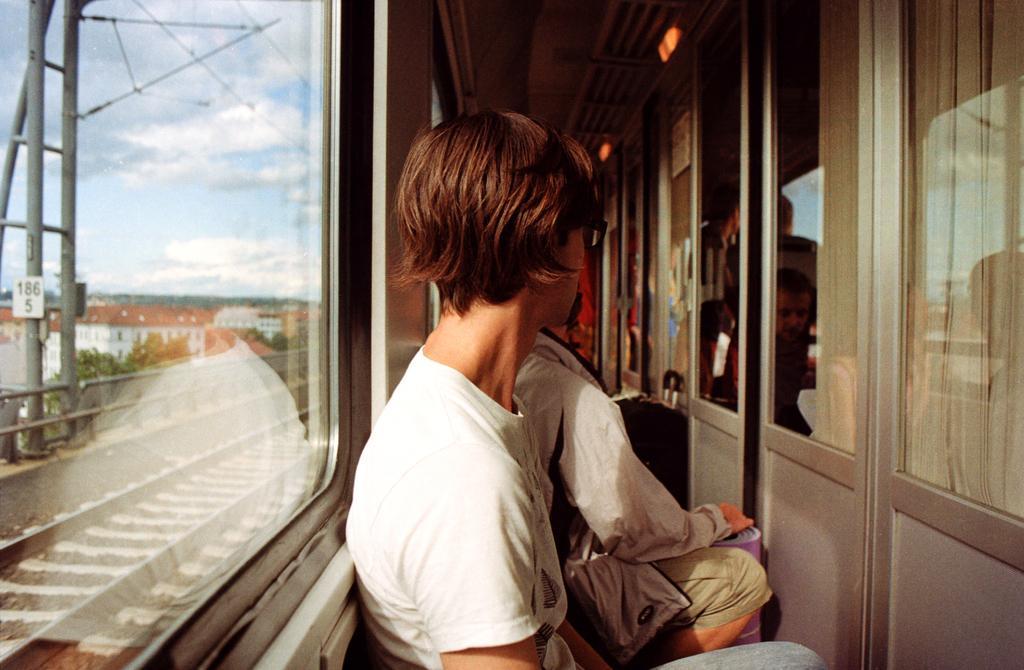Please provide a concise description of this image. In the picture we can see inside the train with glass windows and near it we can see some people are standing and one person is wearing a white T-shirt and holding something, in front of them we can see glass doors and to the ceiling we can see lights and outside of the train we can see some tracks and beside it we can see railing and behind it we can see some trees, buildings and sky with clouds. 